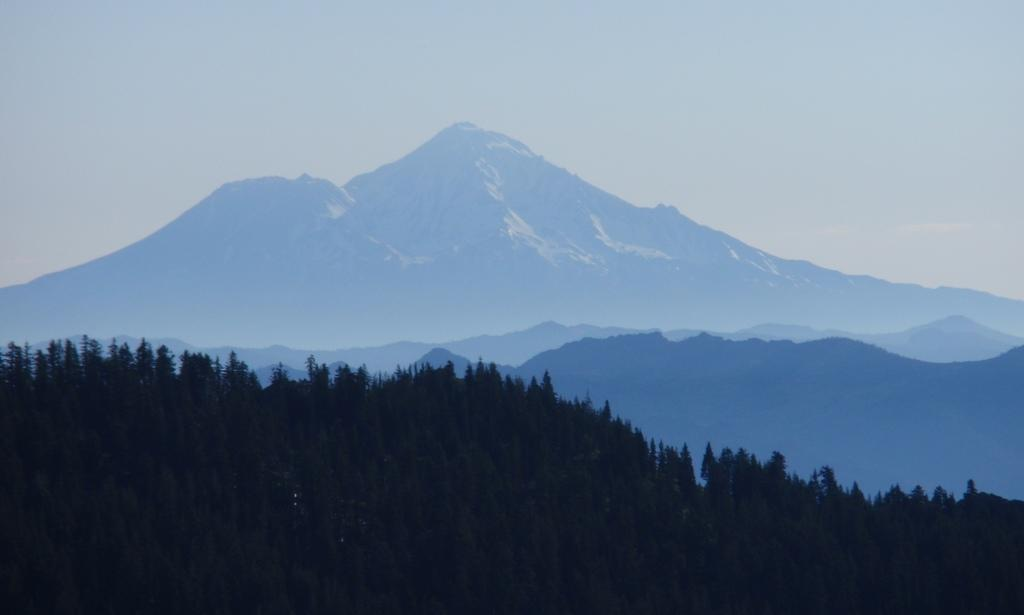What type of landscape can be seen in the image? There are hills in the image. What other natural elements are present in the image? There are trees in the image. What is visible at the top of the image? The sky is visible at the top of the image. How would you describe the lighting in the image? The image is slightly dark. What type of quilt is being used to cover the trees in the image? There is no quilt present in the image; it features hills, trees, and the sky. 